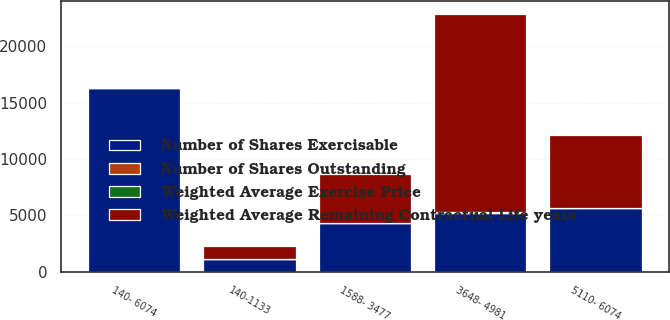Convert chart to OTSL. <chart><loc_0><loc_0><loc_500><loc_500><stacked_bar_chart><ecel><fcel>140-1133<fcel>1588- 3477<fcel>3648- 4981<fcel>5110- 6074<fcel>140- 6074<nl><fcel>Weighted Average Remaining Contractual Life years<fcel>1141<fcel>4372<fcel>17583<fcel>6470<fcel>54.89<nl><fcel>Number of Shares Outstanding<fcel>1.7<fcel>4.5<fcel>8.5<fcel>7.1<fcel>7.3<nl><fcel>Weighted Average Exercise Price<fcel>10.42<fcel>30.49<fcel>42.38<fcel>54.89<fcel>42.13<nl><fcel>Number of Shares Exercisable<fcel>1129<fcel>4293<fcel>5226<fcel>5633<fcel>16281<nl></chart> 